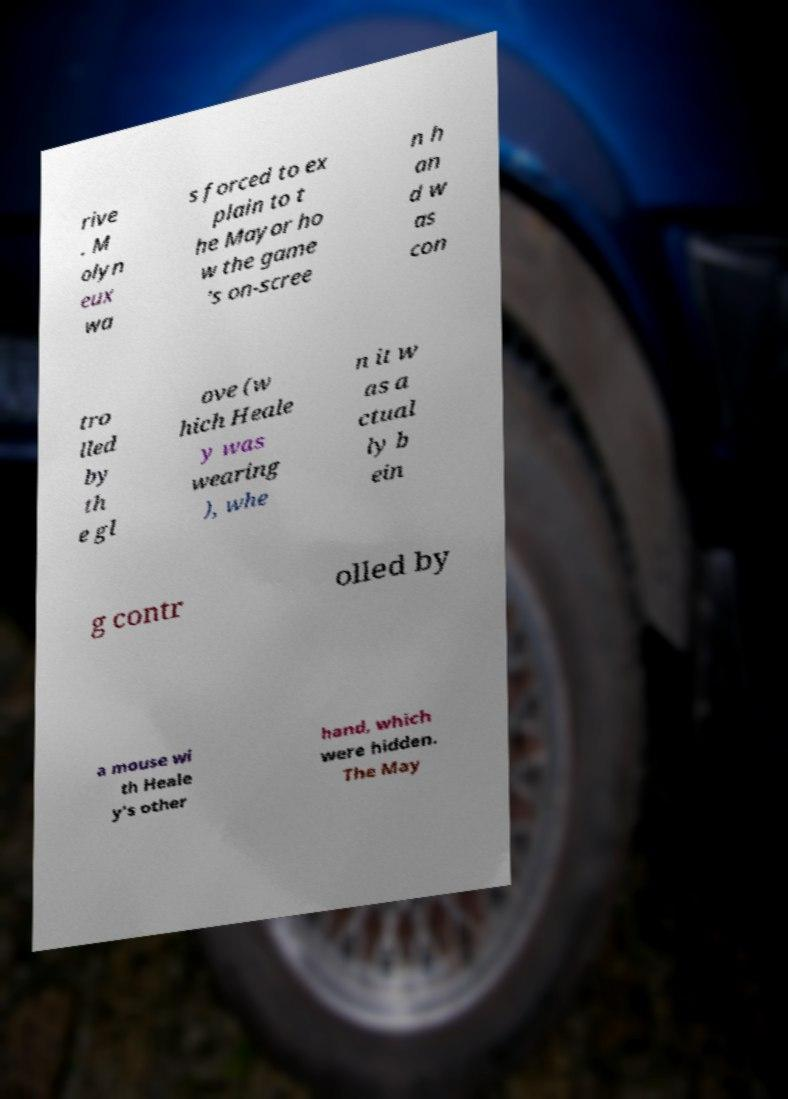There's text embedded in this image that I need extracted. Can you transcribe it verbatim? rive . M olyn eux wa s forced to ex plain to t he Mayor ho w the game 's on-scree n h an d w as con tro lled by th e gl ove (w hich Heale y was wearing ), whe n it w as a ctual ly b ein g contr olled by a mouse wi th Heale y's other hand, which were hidden. The May 